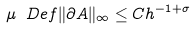<formula> <loc_0><loc_0><loc_500><loc_500>\mu \ D e f \| \partial A \| _ { \infty } \leq C h ^ { - 1 + \sigma }</formula> 